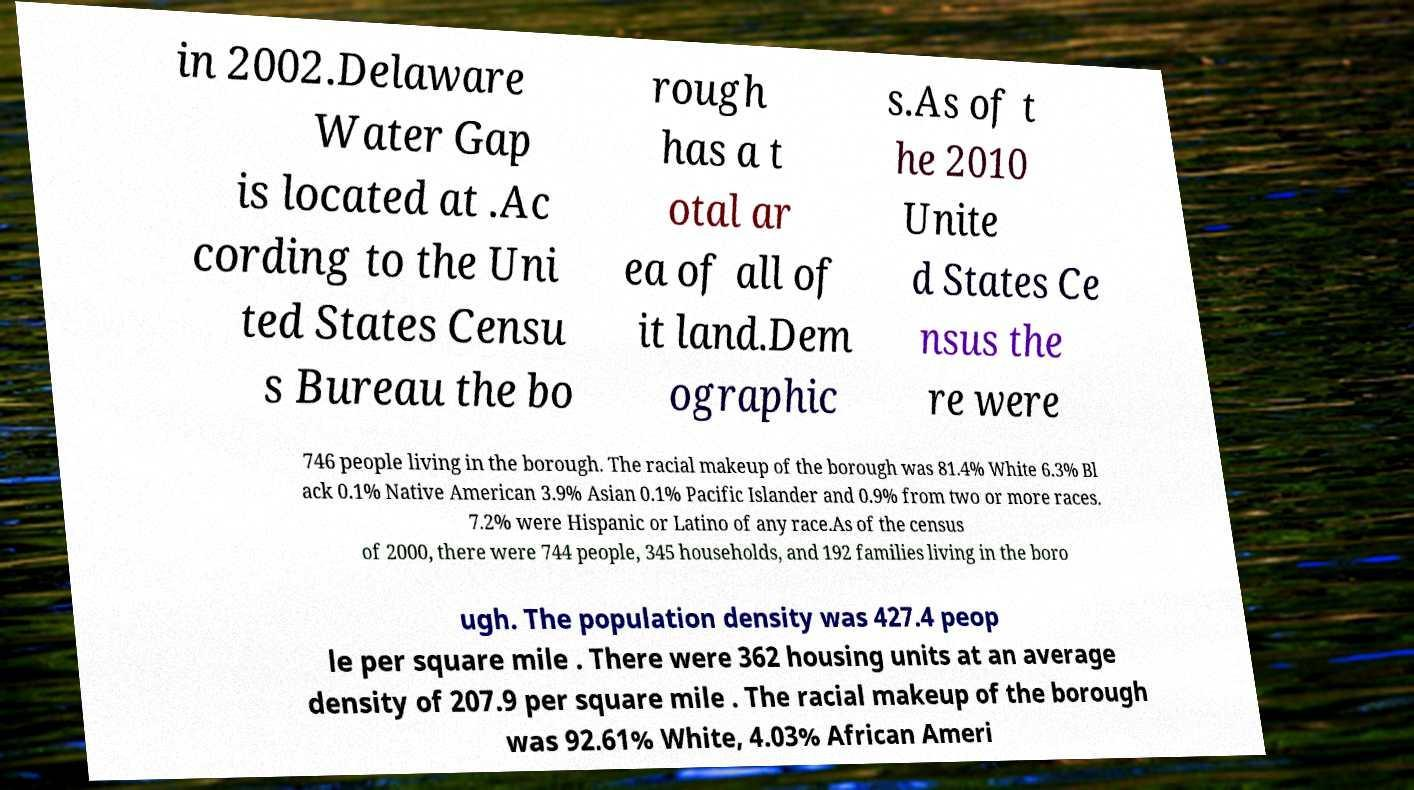Please identify and transcribe the text found in this image. in 2002.Delaware Water Gap is located at .Ac cording to the Uni ted States Censu s Bureau the bo rough has a t otal ar ea of all of it land.Dem ographic s.As of t he 2010 Unite d States Ce nsus the re were 746 people living in the borough. The racial makeup of the borough was 81.4% White 6.3% Bl ack 0.1% Native American 3.9% Asian 0.1% Pacific Islander and 0.9% from two or more races. 7.2% were Hispanic or Latino of any race.As of the census of 2000, there were 744 people, 345 households, and 192 families living in the boro ugh. The population density was 427.4 peop le per square mile . There were 362 housing units at an average density of 207.9 per square mile . The racial makeup of the borough was 92.61% White, 4.03% African Ameri 